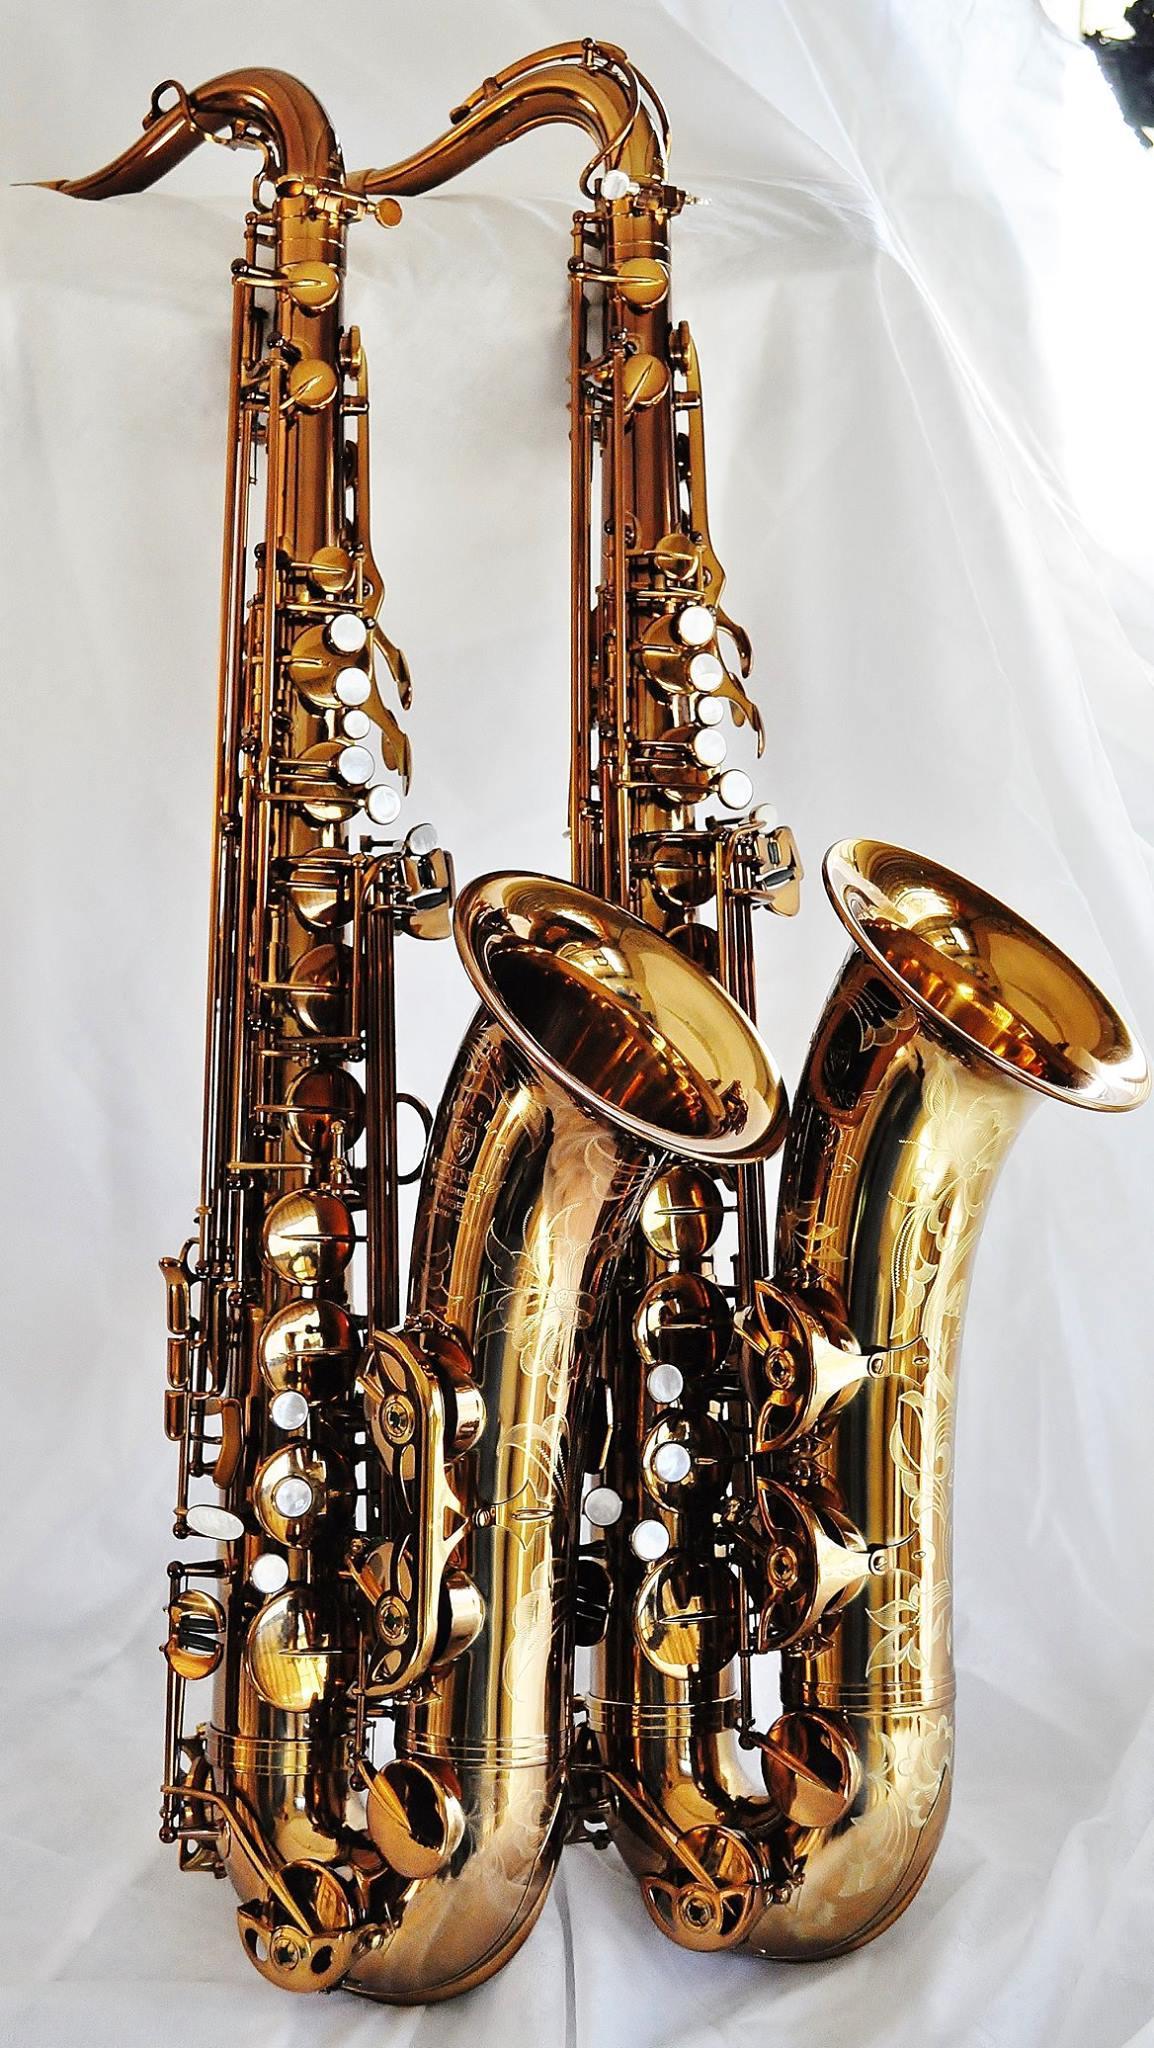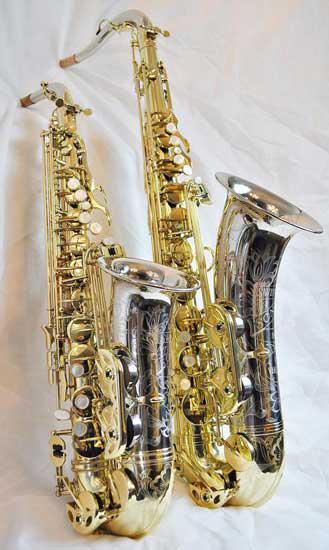The first image is the image on the left, the second image is the image on the right. Examine the images to the left and right. Is the description "The rail of the saxophone is covered light gold and buttons." accurate? Answer yes or no. Yes. The first image is the image on the left, the second image is the image on the right. Considering the images on both sides, is "Each image contains an entire saxophone." valid? Answer yes or no. Yes. 